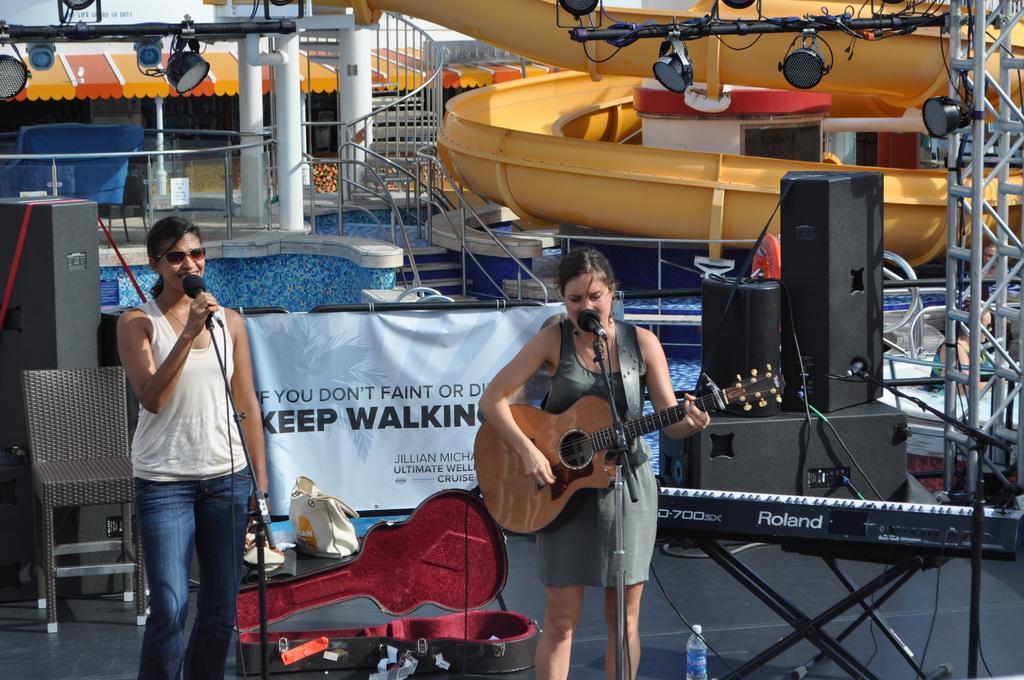Could you give a brief overview of what you see in this image? In this picture there is a woman playing a guitar and singing. There is also other woman who is holding a mic in her hand. There is a bag ,chair. guitar box, bottle on the stage. There is a piano and other objects. There is a light, staircase at the background. 